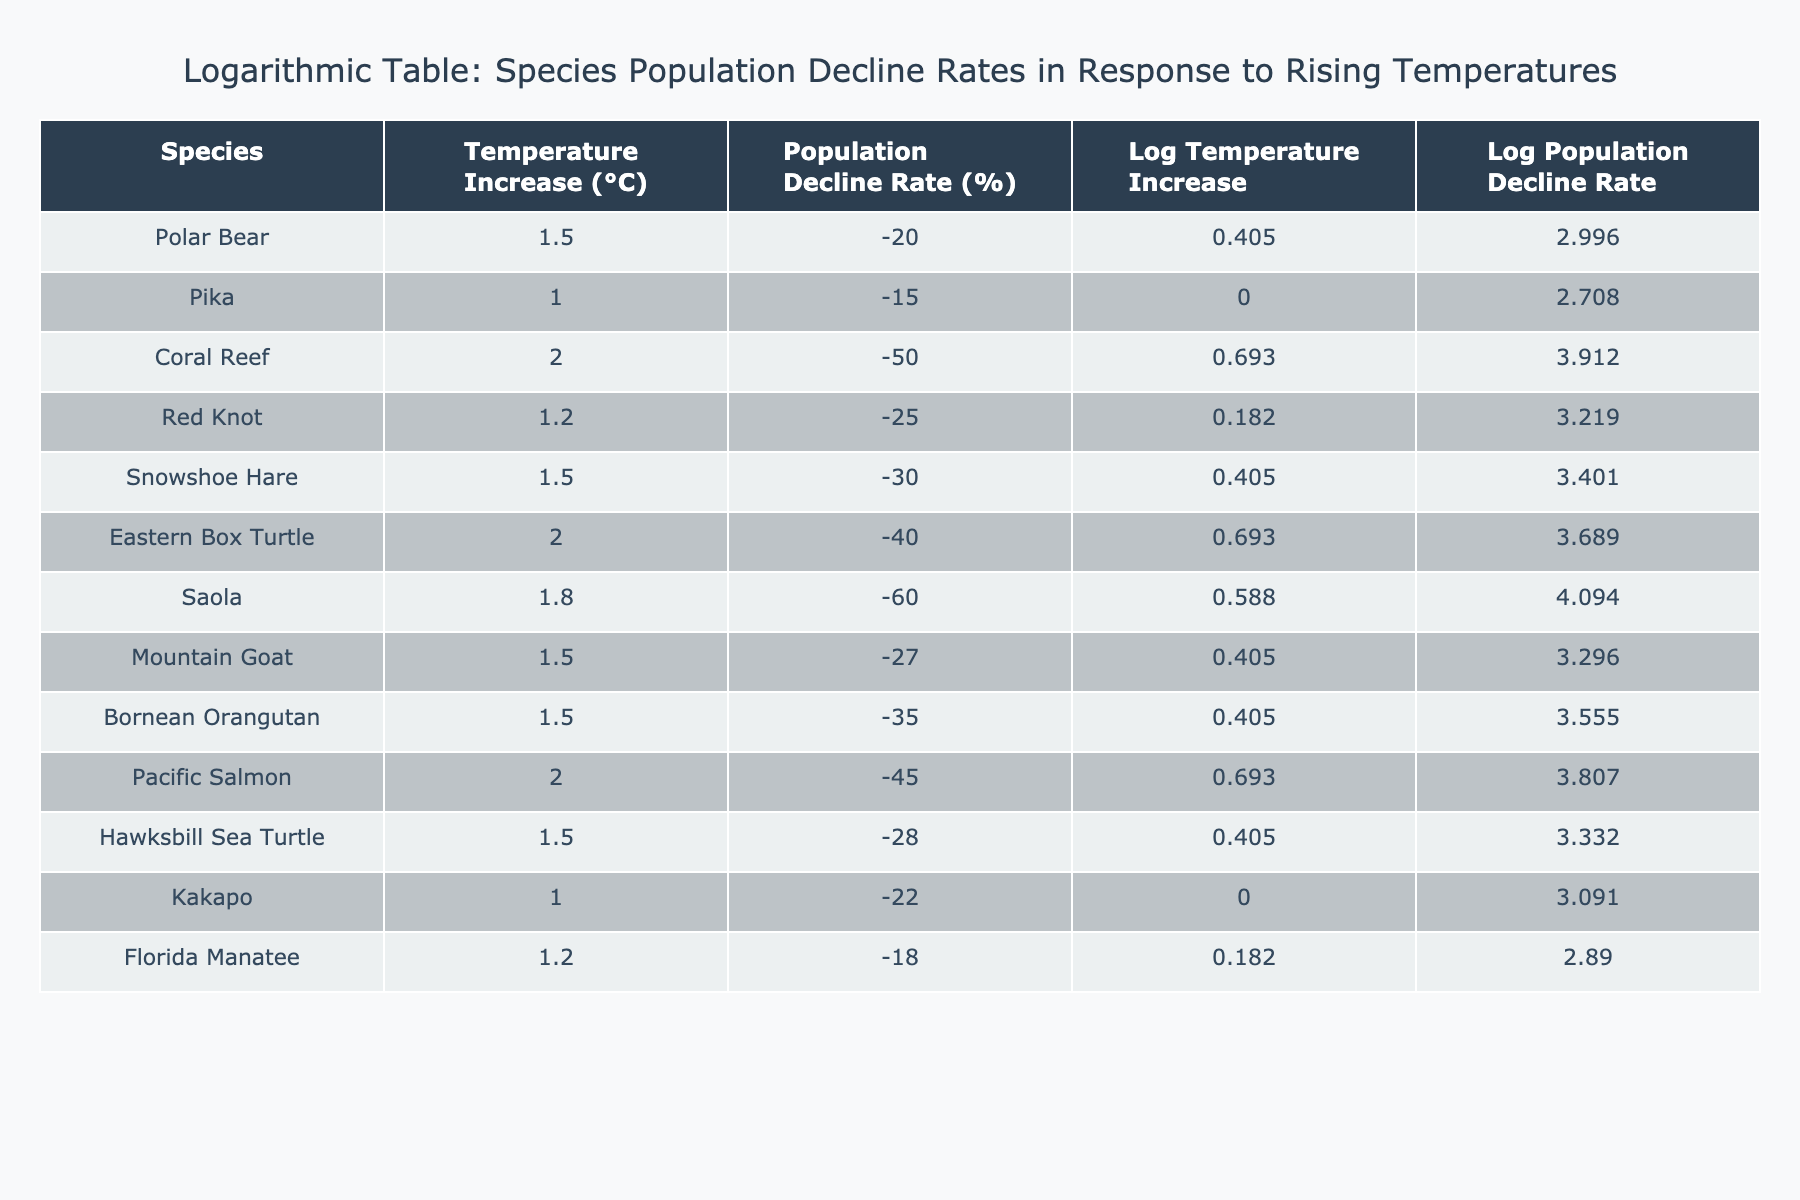What is the population decline rate of the Polar Bear? The population decline rate of the Polar Bear is listed directly in the table as -20%.
Answer: -20% Which species has the highest population decline rate? By inspecting the population decline rates in the table, the Saola has the highest decline rate at -60%.
Answer: -60% What is the average population decline rate for species with a temperature increase of 1.5°C? The species with a temperature increase of 1.5°C are Polar Bear (-20%), Snowshoe Hare (-30%), Mountain Goat (-27%), and Hawksbill Sea Turtle (-28%). Sum them up: -20 + (-30) + (-27) + (-28) = -105. There are 4 species, so the average is -105/4 = -26.25%.
Answer: -26.25% Is the Eastern Box Turtle's population decline rate higher than that of the Coral Reef? The Eastern Box Turtle has a decline rate of -40%, while the Coral Reef has a decline rate of -50%. Comparing these two, -40% is higher than -50%. Thus, the statement is true.
Answer: Yes What is the total population decline rate of species that experience a temperature increase of 2.0°C? The species with a temperature increase of 2.0°C are Coral Reef (-50%), Eastern Box Turtle (-40%), and Pacific Salmon (-45%). Summing these rates gives -50 + (-40) + (-45) = -135%.
Answer: -135% Which species has the lowest temperature increase and what is its population decline rate? The Pika has the lowest temperature increase at 1.0°C, with a population decline rate of -15%, as stated in the table.
Answer: Pika, -15% What is the difference between the population decline rates for Pika and Florida Manatee? The decline rate for Pika is -15% and for Florida Manatee is -18%. The difference is calculated as -15 - (-18) = -15 + 18 = 3%.
Answer: 3% Are there more species with a population decline rate of less than -30% or more than -30%? The species with decline rates less than -30% are Polar Bear (-20%), Pika (-15%), and Florida Manatee (-18%). There are 3. The species with rates more than -30% are Coral Reef (-50%), Saola (-60%), Eastern Box Turtle (-40%), Pacific Salmon (-45%), Red Knot (-25%), and Hawksbill Sea Turtle (-28%). There are 5. Since 3 is less than 5, there are more species with decline rates more than -30%.
Answer: More species with decline rates > -30% 